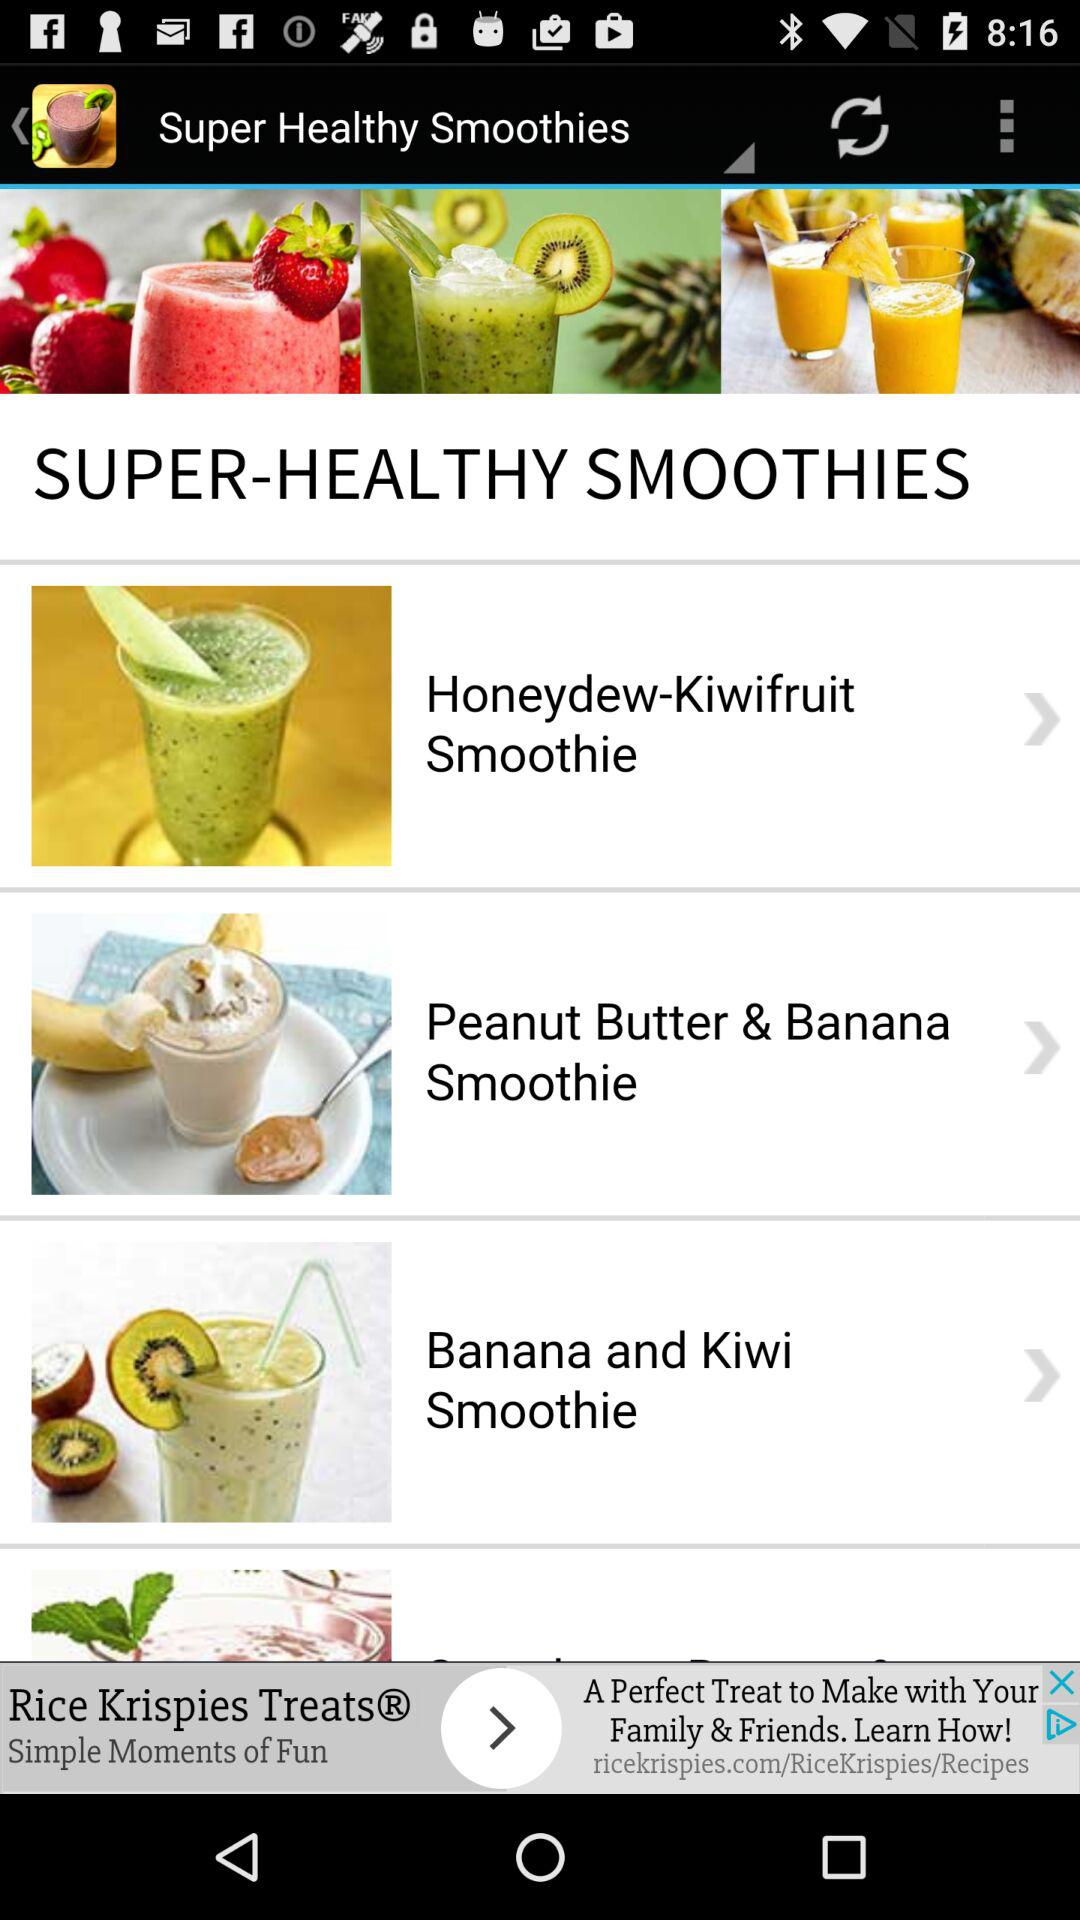What are the different "SUPER-HEALTHY SMOOTHIES" that I can select? The different "SUPER-HEALTHY SMOOTHIES" that you can select are "Honeydew-Kiwifruit Smoothie", "Peanut Butter & Banana Smoothie" and "Banana and Kiwi Smoothie". 